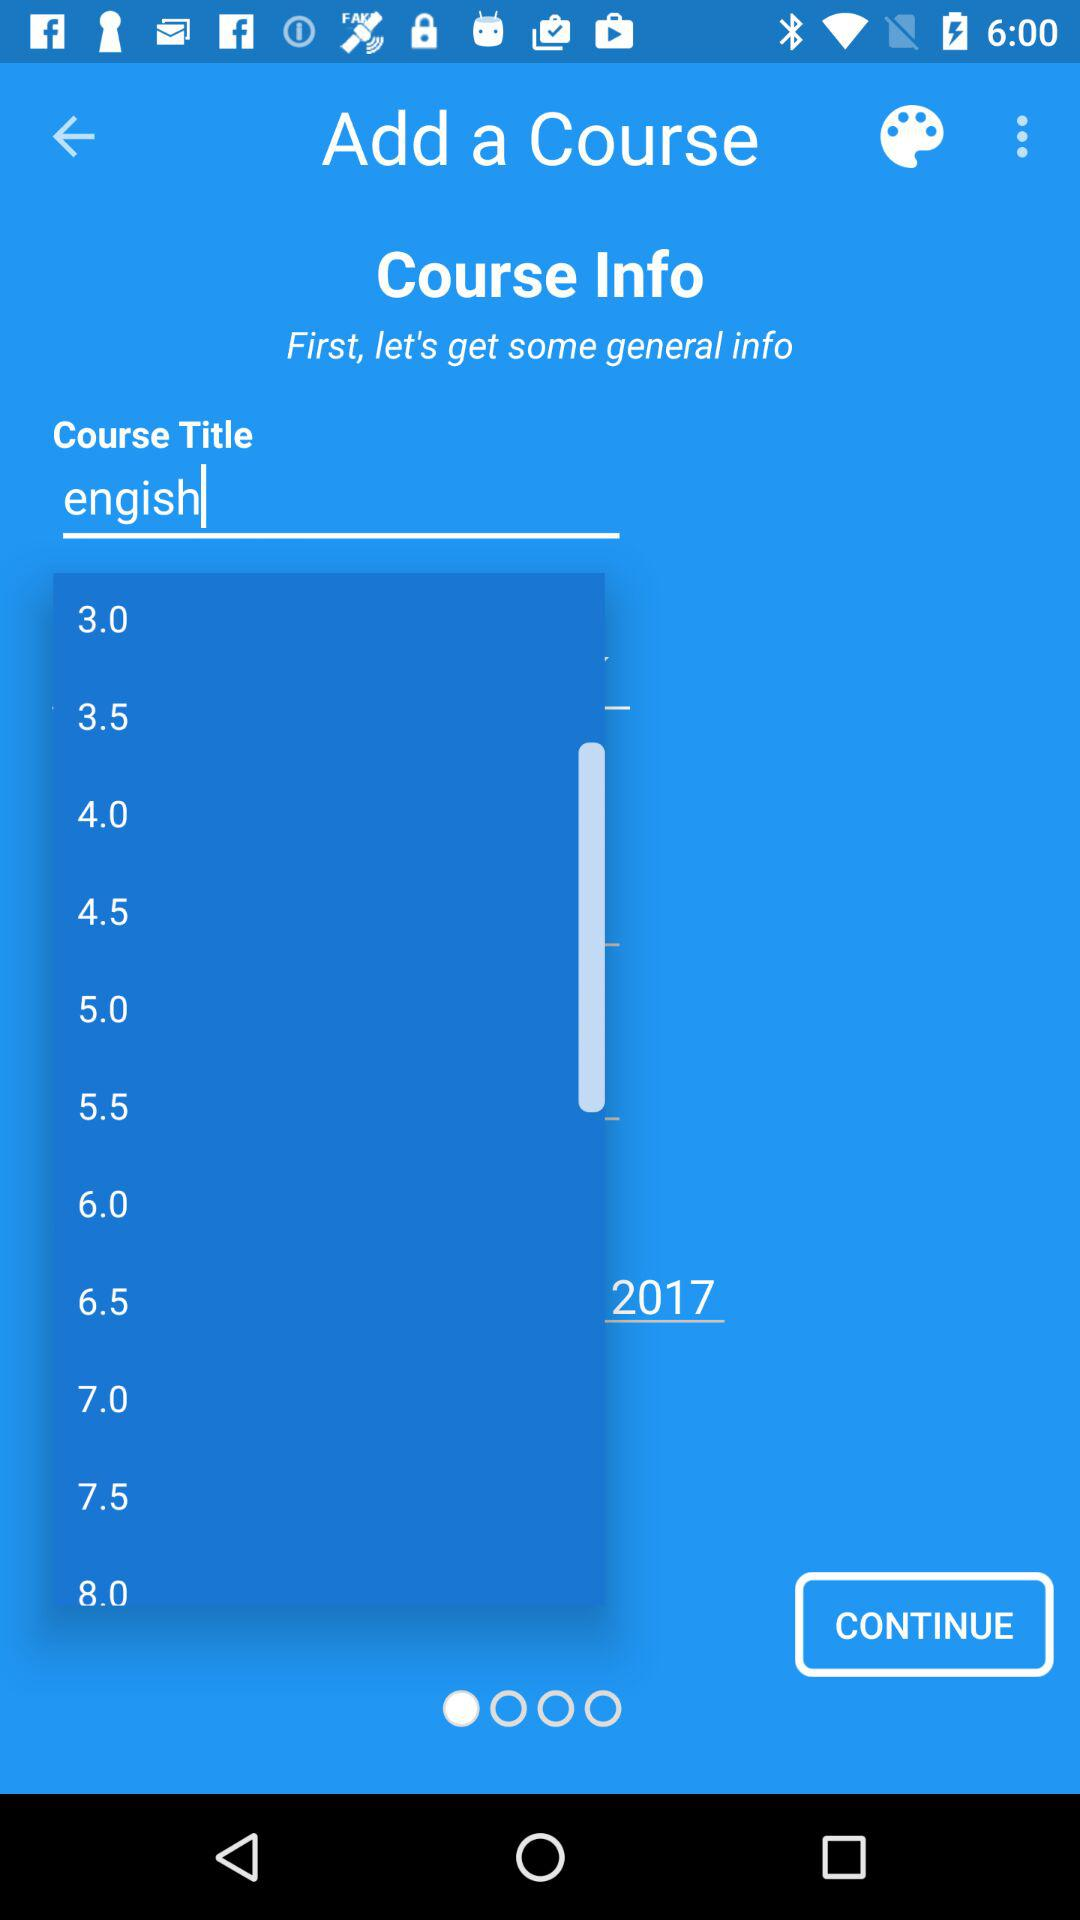Which language is used in the course title?
When the provided information is insufficient, respond with <no answer>. <no answer> 